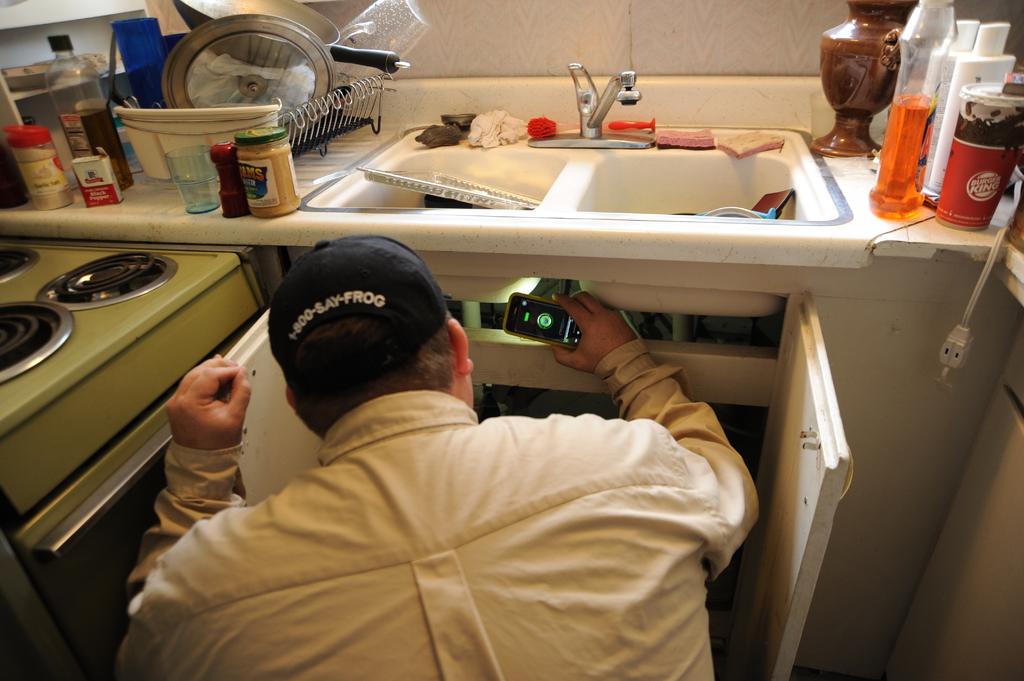What's the phone number on the back of his hat?
Offer a very short reply. 1-800-say-frog. What is one of the spices on the counter?
Provide a short and direct response. Black pepper. 